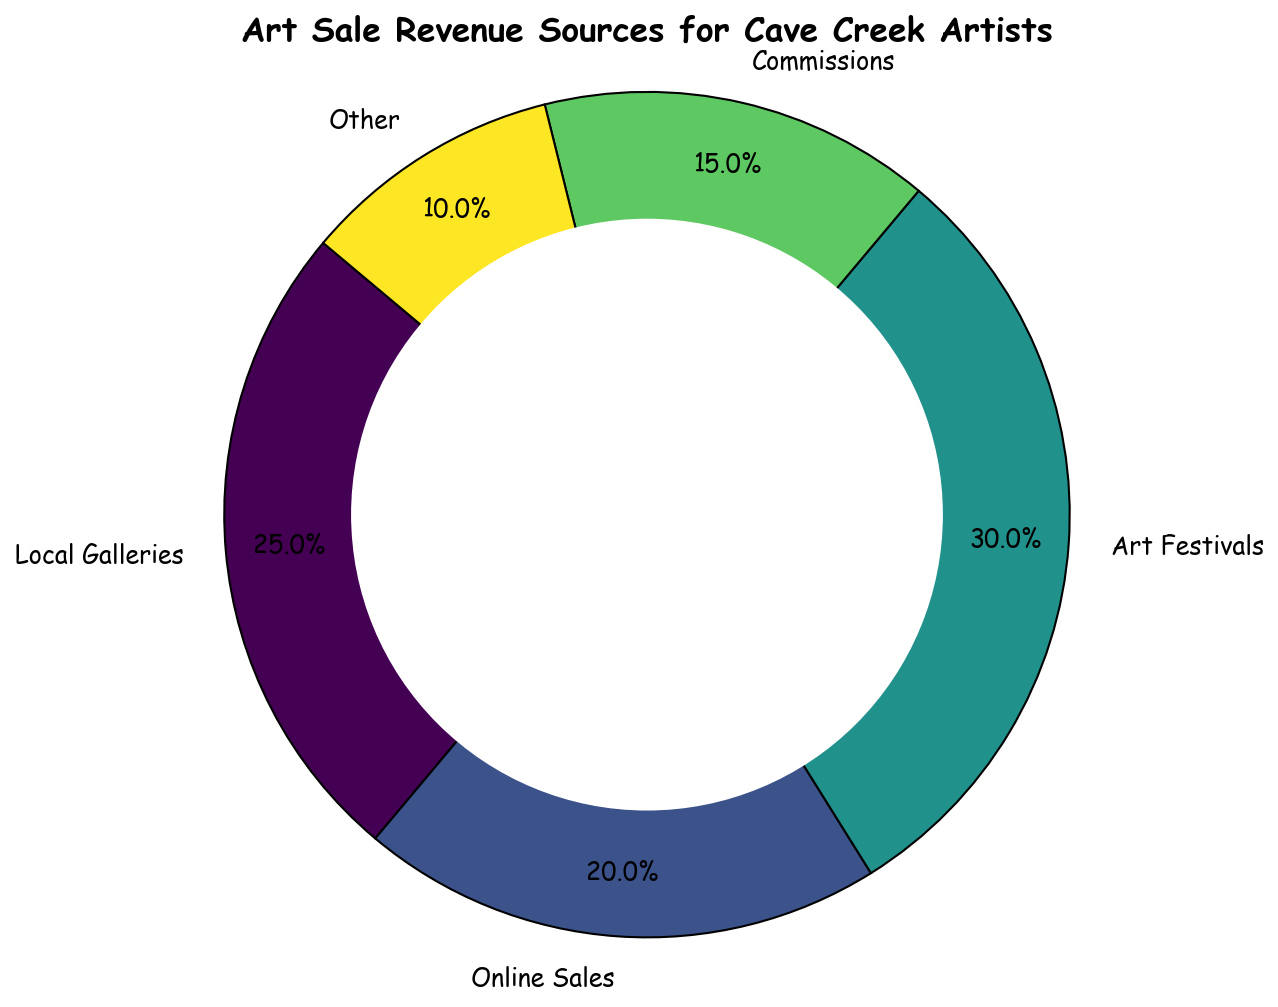What is the largest revenue source for Cave Creek Artists? The largest revenue source can be determined by identifying the category with the highest percentage in the pie chart. The Art Festivals segment displays the largest value at 30%.
Answer: Art Festivals Which revenue source contributes the least to the total revenue? The revenue source with the smallest percentage in the pie chart is the one contributing the least. The "Other" category is the smallest and contributes 10%.
Answer: Other How much more revenue do Art Festivals generate compared to Commissions? To find how much more revenue Art Festivals generate compared to Commissions, subtract the percentage of Commissions from that of Art Festivals: 30% (Art Festivals) - 15% (Commissions) = 15%.
Answer: 15% What is the total percentage contributed by Local Galleries and Online Sales? To find the total percentage contributed by both, add the percentages of Local Galleries and Online Sales: 25% (Local Galleries) + 20% (Online Sales) = 45%.
Answer: 45% Between Local Galleries and Art Festivals, which one has a higher percentage, and by how much? Compare the percentages of Local Galleries and Art Festivals: Art Festivals have 30% while Local Galleries have 25%. Subtract 25% from 30% to find the difference: 5%.
Answer: Art Festivals by 5% What is the average percentage of revenue sources other than Art Festivals? To find the average percentage of the other categories (Local Galleries, Online Sales, Commissions, Other), sum their percentages and divide by the number of categories: (25% + 20% + 15% + 10%) / 4 = 17.5%.
Answer: 17.5% How do Online Sales compare visually to Commissions in terms of space taken in the plot? Online Sales, at 20%, take up more space in the pie chart compared to Commissions, which are at 15%. This is visually seen as a larger segment for Online Sales.
Answer: Online Sales take up more space What is the combined percentage for Online Sales and Commissions compared to Art Festivals? To compare the combined percentage of Online Sales and Commissions to Art Festivals, sum Online Sales and Commissions (20% + 15% = 35%) and compare it to Art Festivals: 35% > 30%.
Answer: 35% (higher than Art Festivals' 30%) Based on visual size, which segment is the third largest? Visually inspecting the pie chart, the third largest segment after Art Festivals (30%) and Local Galleries (25%) is Online Sales, which is 20%.
Answer: Online Sales 